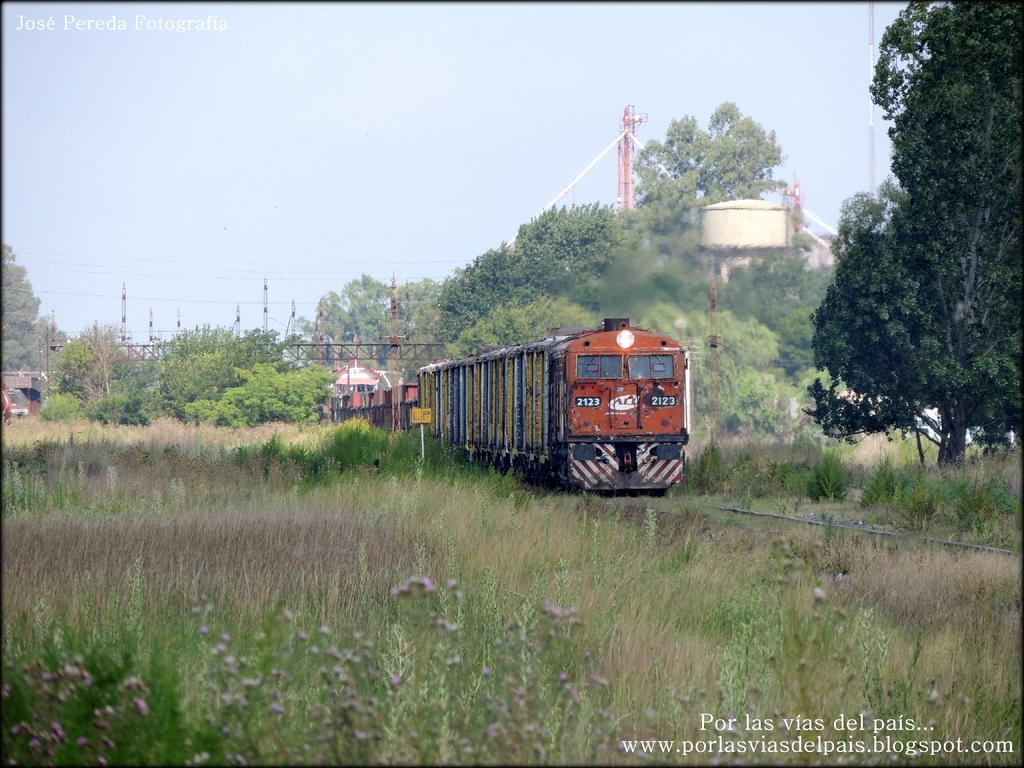What numbers are on front of the train\?
Your answer should be compact. 2123. 